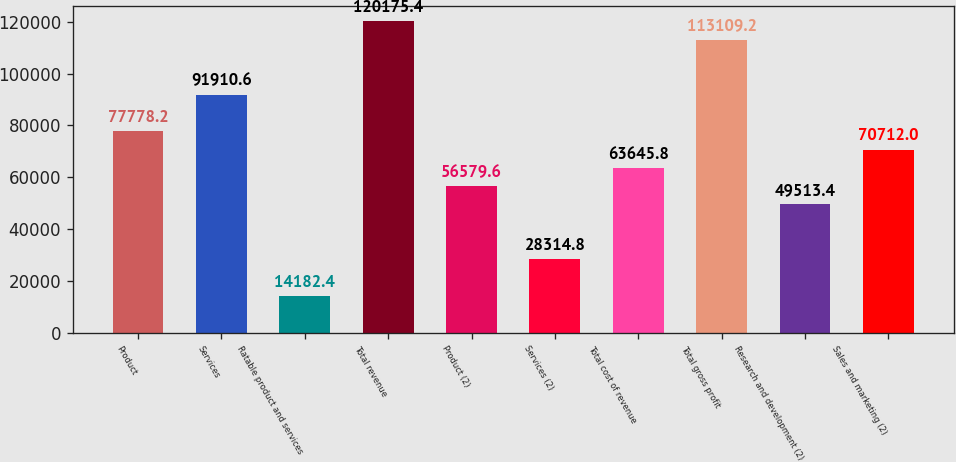Convert chart to OTSL. <chart><loc_0><loc_0><loc_500><loc_500><bar_chart><fcel>Product<fcel>Services<fcel>Ratable product and services<fcel>Total revenue<fcel>Product (2)<fcel>Services (2)<fcel>Total cost of revenue<fcel>Total gross profit<fcel>Research and development (2)<fcel>Sales and marketing (2)<nl><fcel>77778.2<fcel>91910.6<fcel>14182.4<fcel>120175<fcel>56579.6<fcel>28314.8<fcel>63645.8<fcel>113109<fcel>49513.4<fcel>70712<nl></chart> 